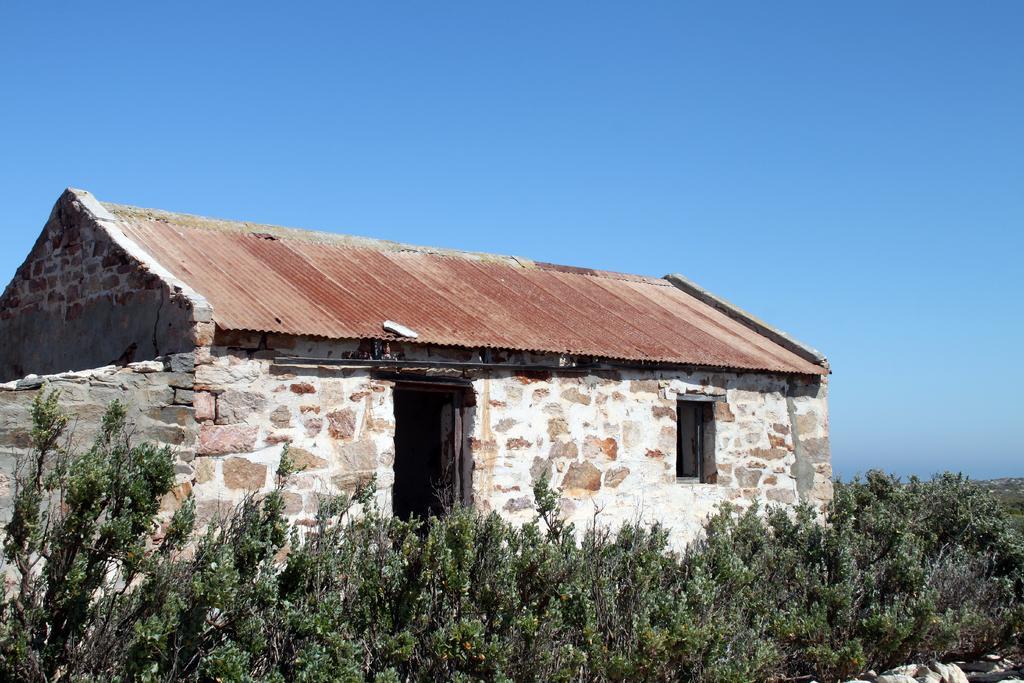Can you describe this image briefly? In this image, we can see a roof house. There are some plants at the bottom of the image. At the top of the image, we can see the sky. 